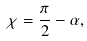Convert formula to latex. <formula><loc_0><loc_0><loc_500><loc_500>\chi = \frac { \pi } { 2 } - \alpha ,</formula> 